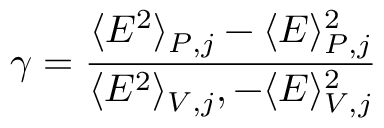Convert formula to latex. <formula><loc_0><loc_0><loc_500><loc_500>\gamma = \frac { \langle E ^ { 2 } \rangle _ { P , j } - \langle E \rangle _ { P , j } ^ { 2 } } { \langle E ^ { 2 } \rangle _ { V , j } , - \langle E \rangle _ { V , j } ^ { 2 } }</formula> 